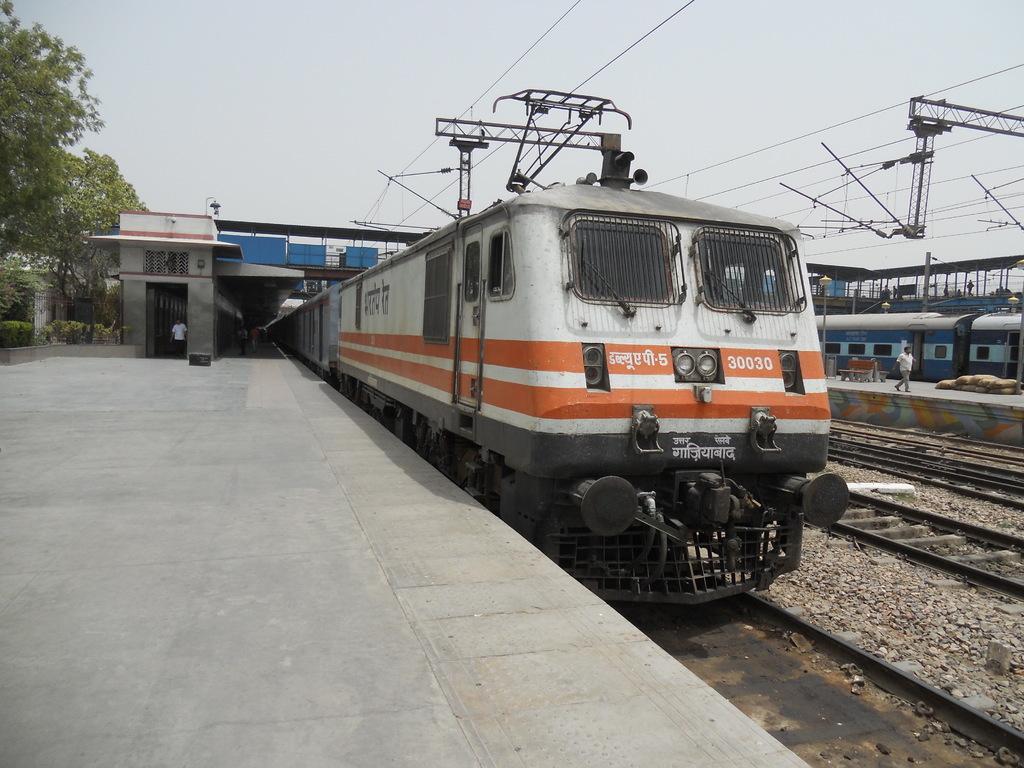Can you describe this image briefly? In this image in the center there are two trains, and at the bottom there is a railway track and some stones. In the center there is one man who is walking and in the background there are some pillars and some wires and towers. On the left side there is a walkway and some trees, on the top of the image there is sky. 